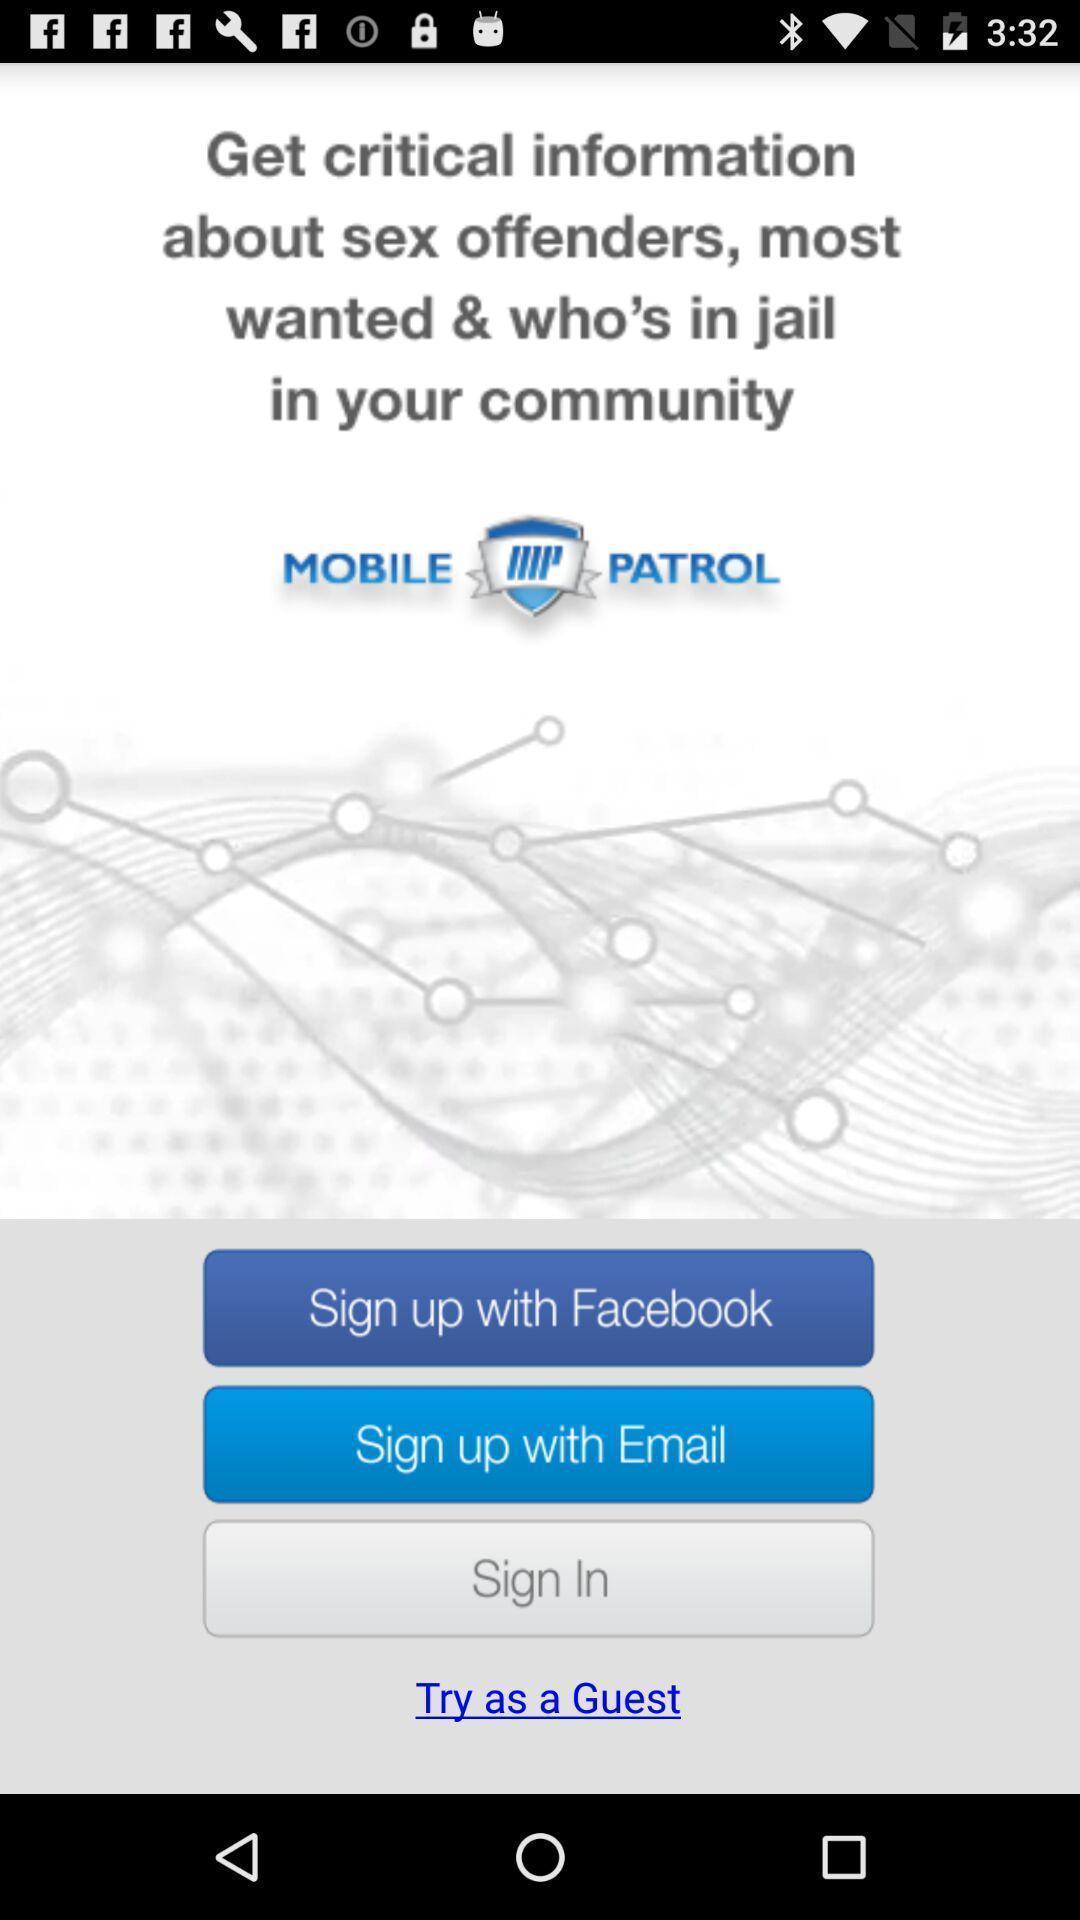Describe the content in this image. Welcome to the sign in page. 